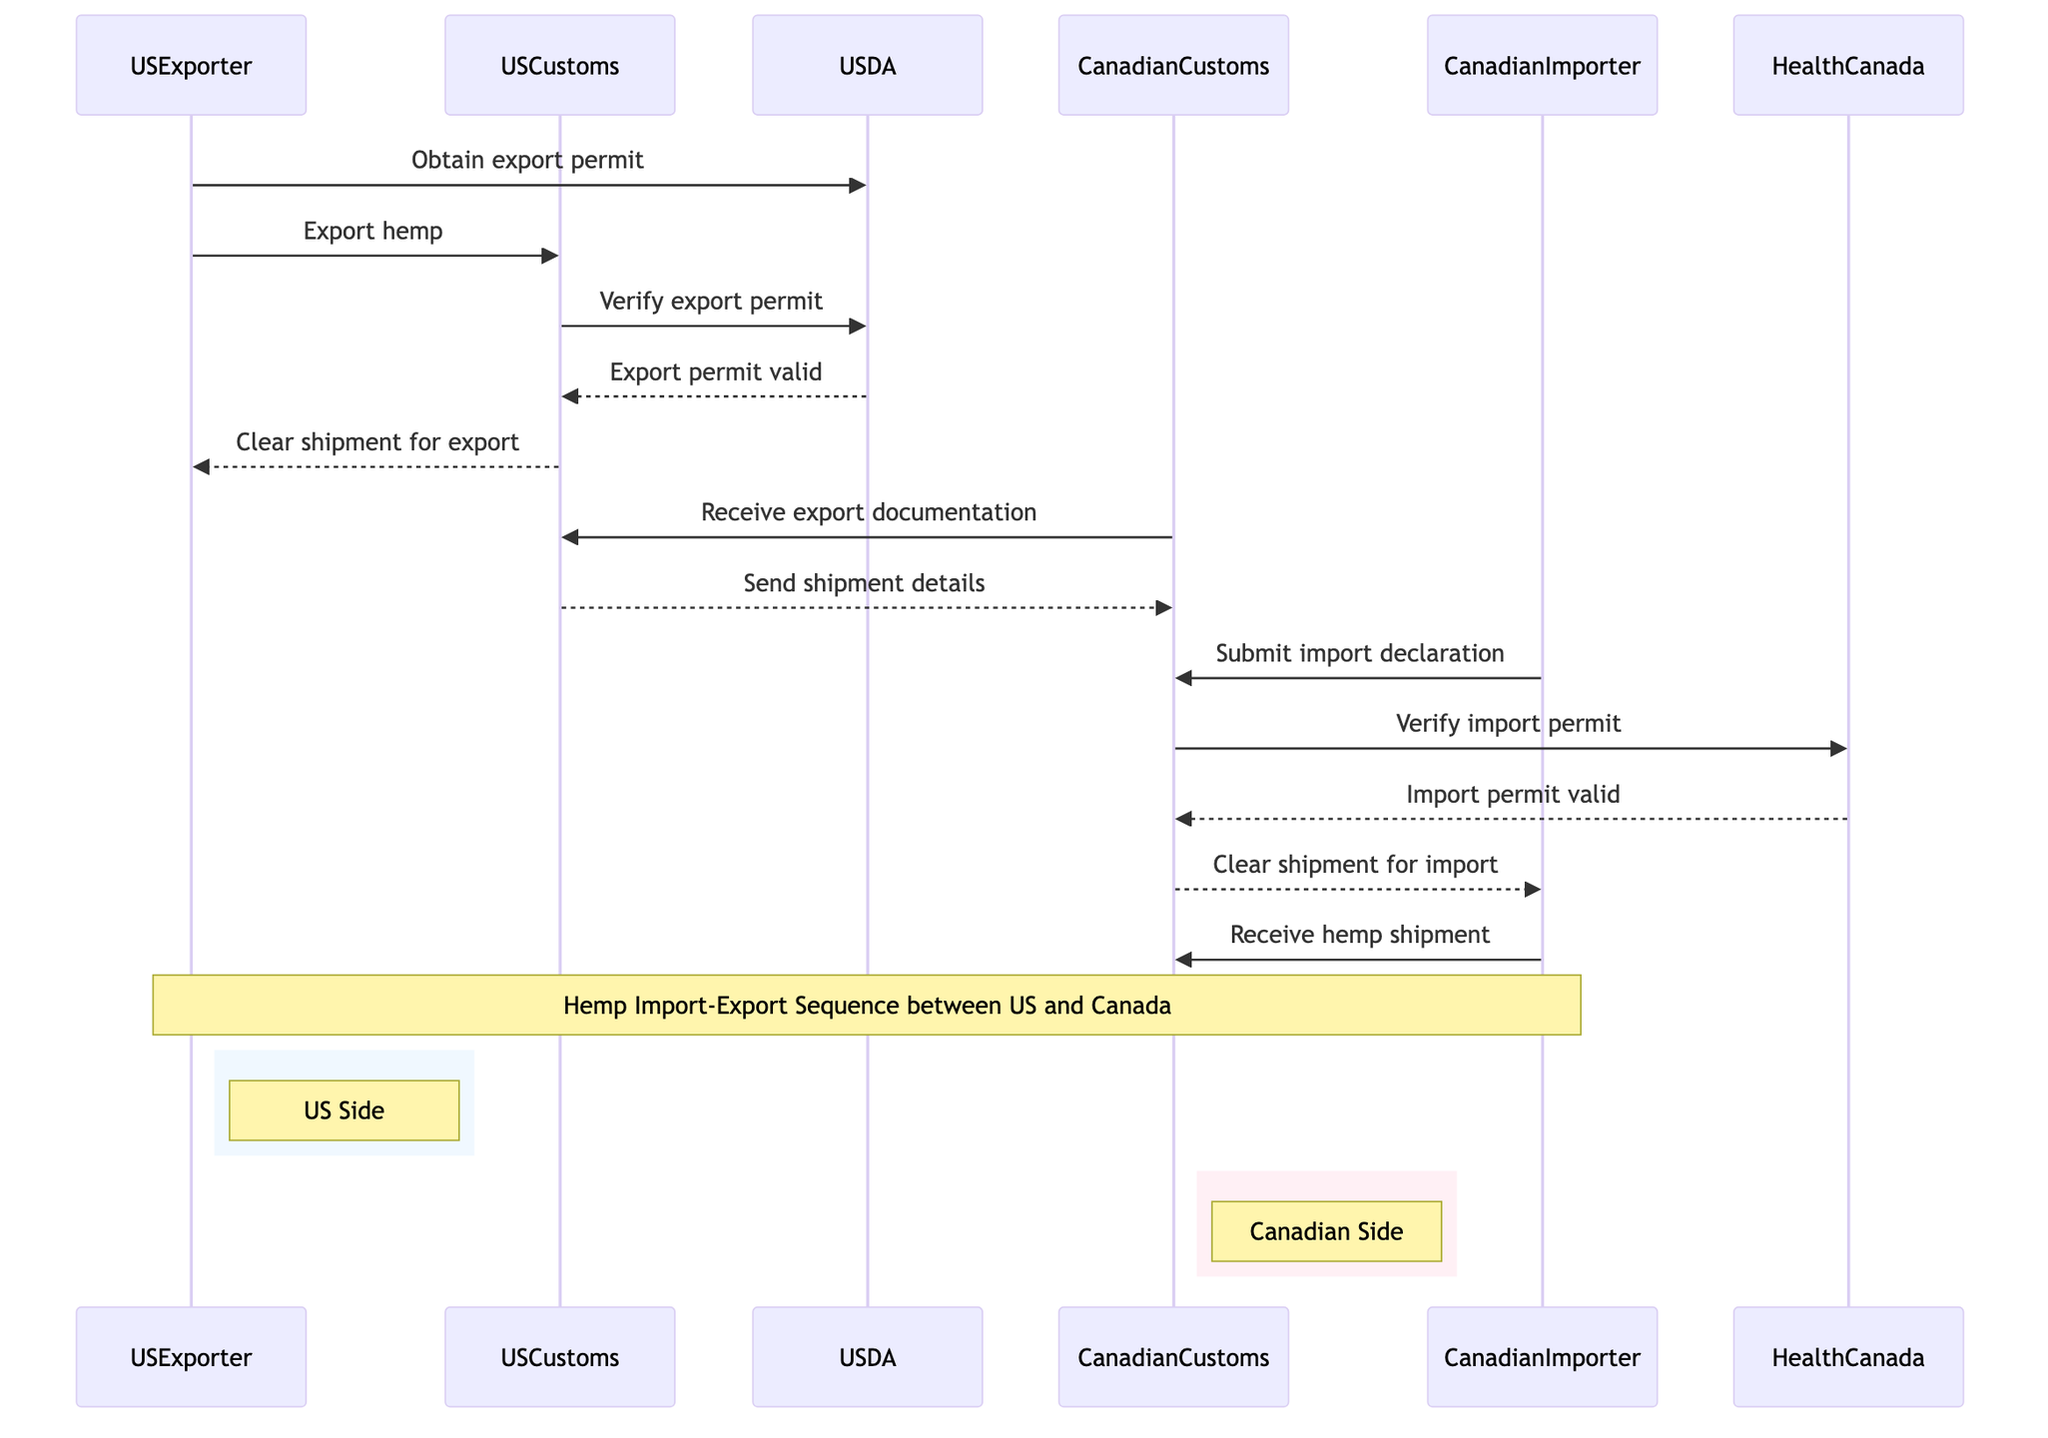What is the first action taken by the USExporter? The diagram shows that the first action is to obtain an export permit. This action initiates the sequence of messages required for the export process.
Answer: Obtain export permit How many actors are involved in the export-import sequence? By counting the participants listed in the diagram, we identify six actors: USExporter, CanadianImporter, USCustoms, CanadianCustoms, USDA, and HealthCanada.
Answer: Six Which entity verifies the export permit? The diagram indicates that USCustoms sends a request to USDA to verify the export permit, making USDA the entity that verifies it.
Answer: USDA What action does CanadianImporter take after the import declaration? The CanadianImporter receives the hemp shipment after the CanadianCustoms clears the shipment for import, as shown in the message sequence.
Answer: Receive hemp shipment What is the response from HealthCanada regarding the import permit? HealthCanada responds to CanadianCustoms by confirming that the import permit is valid, as depicted by the message flow in the diagram.
Answer: Import permit valid Which two customs agencies are involved in sending shipment details? The diagram illustrates a communication between USCustoms and CanadianCustoms, where USCustoms sends the shipment details to CanadianCustoms.
Answer: USCustoms and CanadianCustoms What happens after USCustoms verifies the export permit? Once USCustoms verifies the export permit, USDA validates it, and USCustoms subsequently clears the shipment for export to the USExporter. This sequence is detailed step-by-step in the diagram.
Answer: Clear shipment for export How many messages are exchanged between entities in this sequence? The diagram lists a total of 12 distinct message exchanges among the actors involved in the sequence, indicating the complexity of the import-export process.
Answer: Twelve What does CanadianCustoms do upon receiving the export documentation? Upon receiving the export documentation from USCustoms, CanadianCustoms proceeds to send a verification request regarding the import permit to HealthCanada, as indicated in the sequence.
Answer: Receive export documentation 